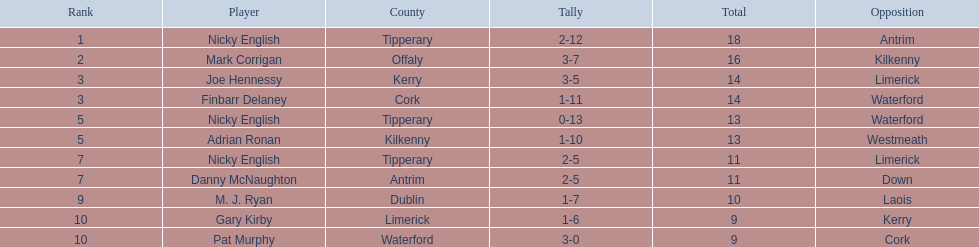Which of the listed athletes were positioned in the last 5? Nicky English, Danny McNaughton, M. J. Ryan, Gary Kirby, Pat Murphy. Of these, whose scores were not 2-5? M. J. Ryan, Gary Kirby, Pat Murphy. From the aforementioned trio, who accumulated over 9 total points? M. J. Ryan. 